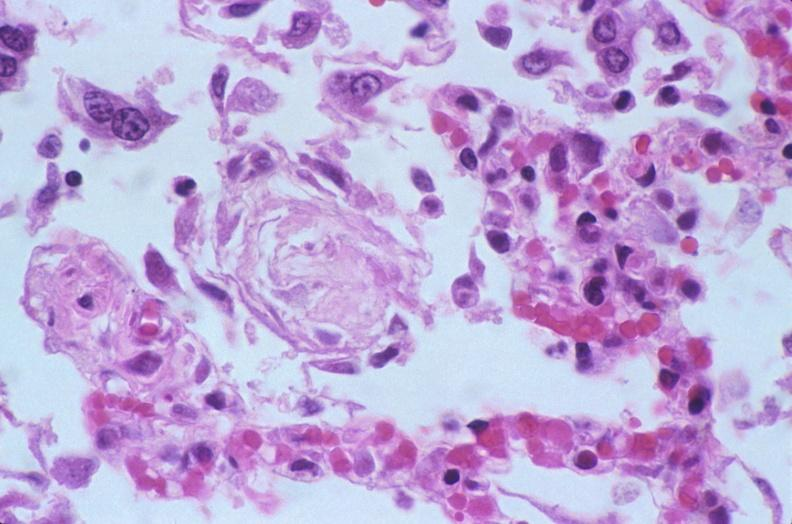where is this?
Answer the question using a single word or phrase. Lung 